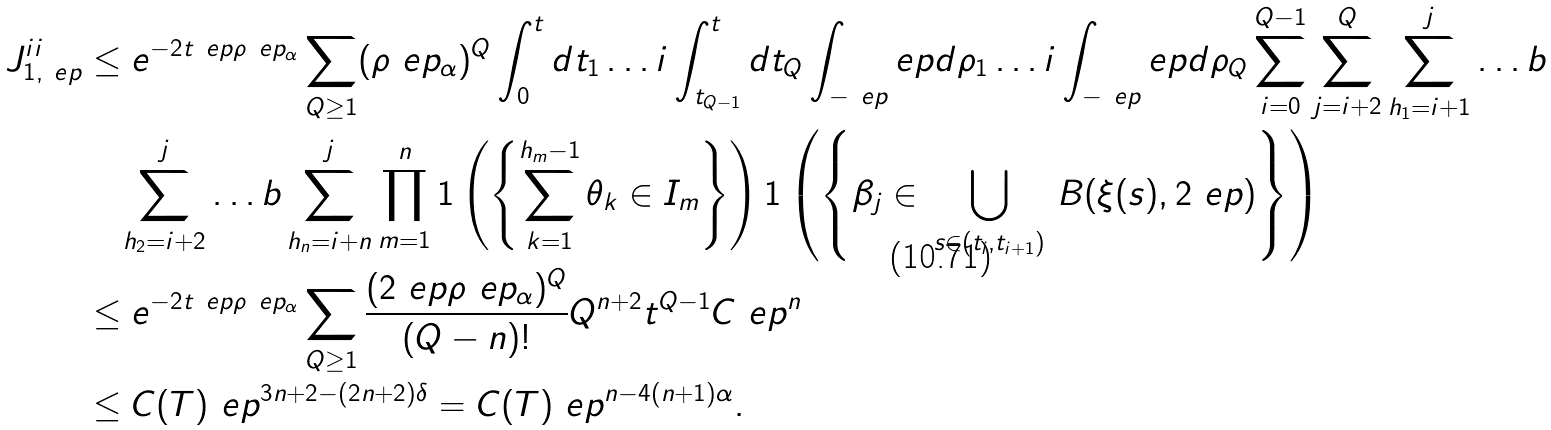Convert formula to latex. <formula><loc_0><loc_0><loc_500><loc_500>J ^ { i i } _ { 1 , \ e p } & \leq e ^ { - 2 t \ e p \rho ^ { \ } e p _ { \alpha } } \sum _ { Q \geq 1 } ( \rho ^ { \ } e p _ { \alpha } ) ^ { Q } \int _ { 0 } ^ { t } d t _ { 1 } \dots i \int _ { t _ { Q - 1 } } ^ { t } d t _ { Q } \int _ { - \ e p } ^ { \ } e p d \rho _ { 1 } \dots i \int _ { - \ e p } ^ { \ } e p d \rho _ { Q } \sum _ { i = 0 } ^ { Q - 1 } \sum _ { j = i + 2 } ^ { Q } \sum _ { h _ { 1 } = i + 1 } ^ { j } \dots b \\ & \quad \sum _ { h _ { 2 } = i + 2 } ^ { j } \dots b \sum _ { h _ { n } = i + n } ^ { j } \prod _ { m = 1 } ^ { n } 1 \left ( \left \{ \sum _ { k = 1 } ^ { h _ { m } - 1 } \theta _ { k } \in I _ { m } \right \} \right ) 1 \left ( \left \{ \beta _ { j } \in \, \bigcup _ { s \in ( t _ { i } , t _ { i + 1 } ) } \, B ( \xi ( s ) , 2 \ e p ) \right \} \right ) \\ & \leq e ^ { - 2 t \ e p \rho ^ { \ } e p _ { \alpha } } \sum _ { Q \geq 1 } \frac { ( 2 \ e p \rho ^ { \ } e p _ { \alpha } ) ^ { Q } } { ( Q - n ) ! } Q ^ { n + 2 } t ^ { Q - 1 } C \ e p ^ { n } \\ & \leq C ( T ) \ e p ^ { 3 n + 2 - ( 2 n + 2 ) \delta } = C ( T ) \ e p ^ { n - 4 ( n + 1 ) \alpha } .</formula> 